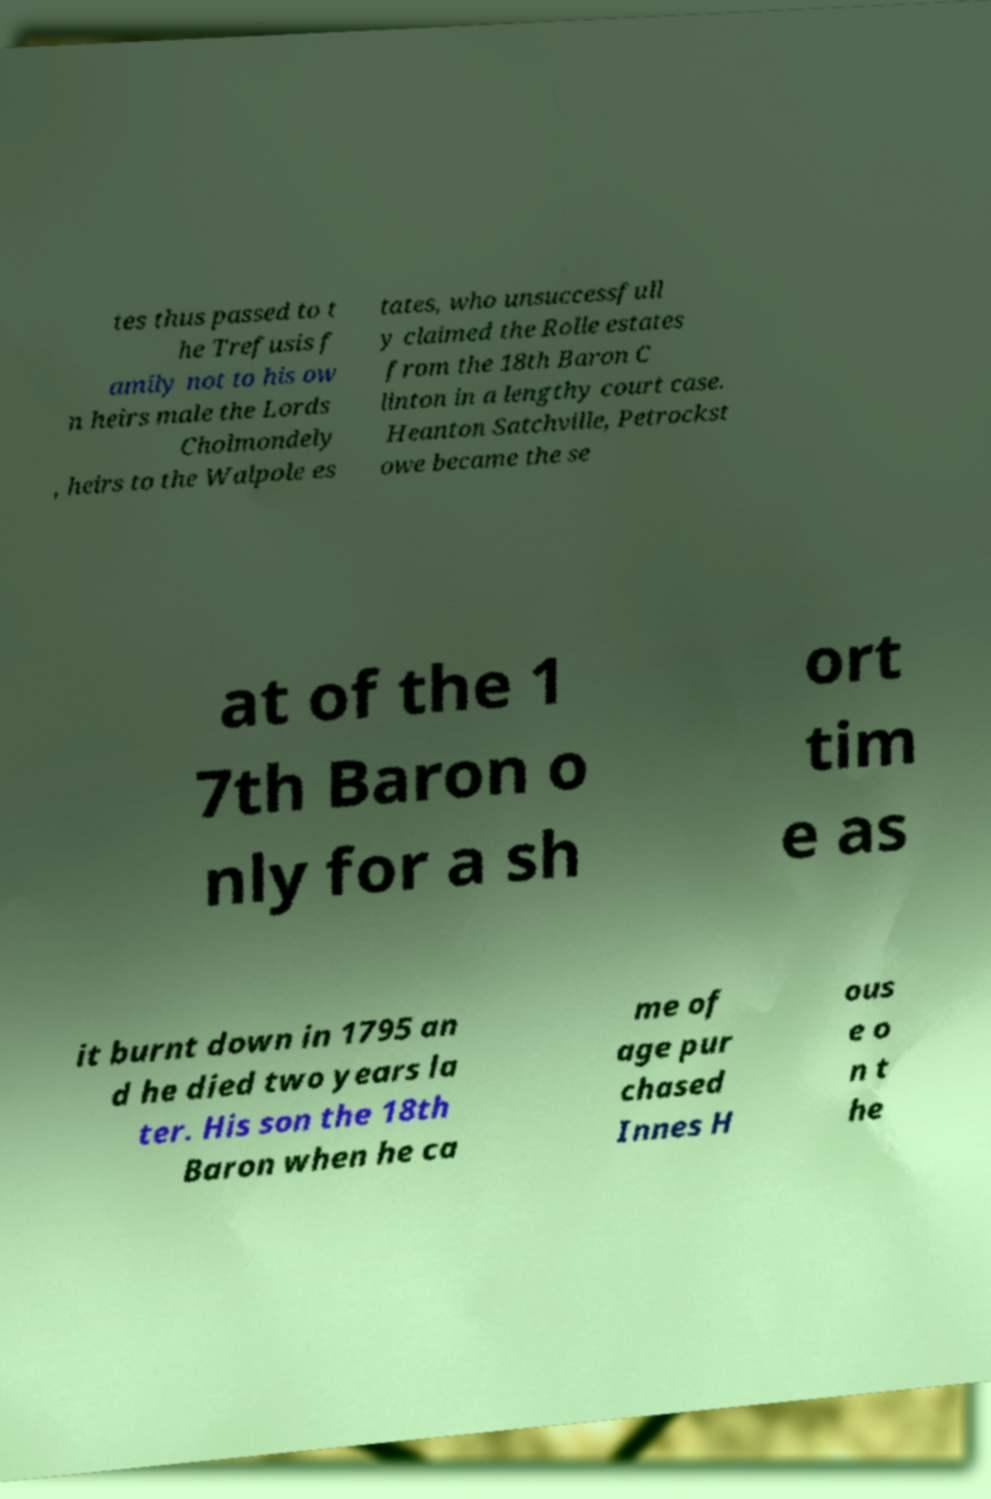Could you extract and type out the text from this image? tes thus passed to t he Trefusis f amily not to his ow n heirs male the Lords Cholmondely , heirs to the Walpole es tates, who unsuccessfull y claimed the Rolle estates from the 18th Baron C linton in a lengthy court case. Heanton Satchville, Petrockst owe became the se at of the 1 7th Baron o nly for a sh ort tim e as it burnt down in 1795 an d he died two years la ter. His son the 18th Baron when he ca me of age pur chased Innes H ous e o n t he 